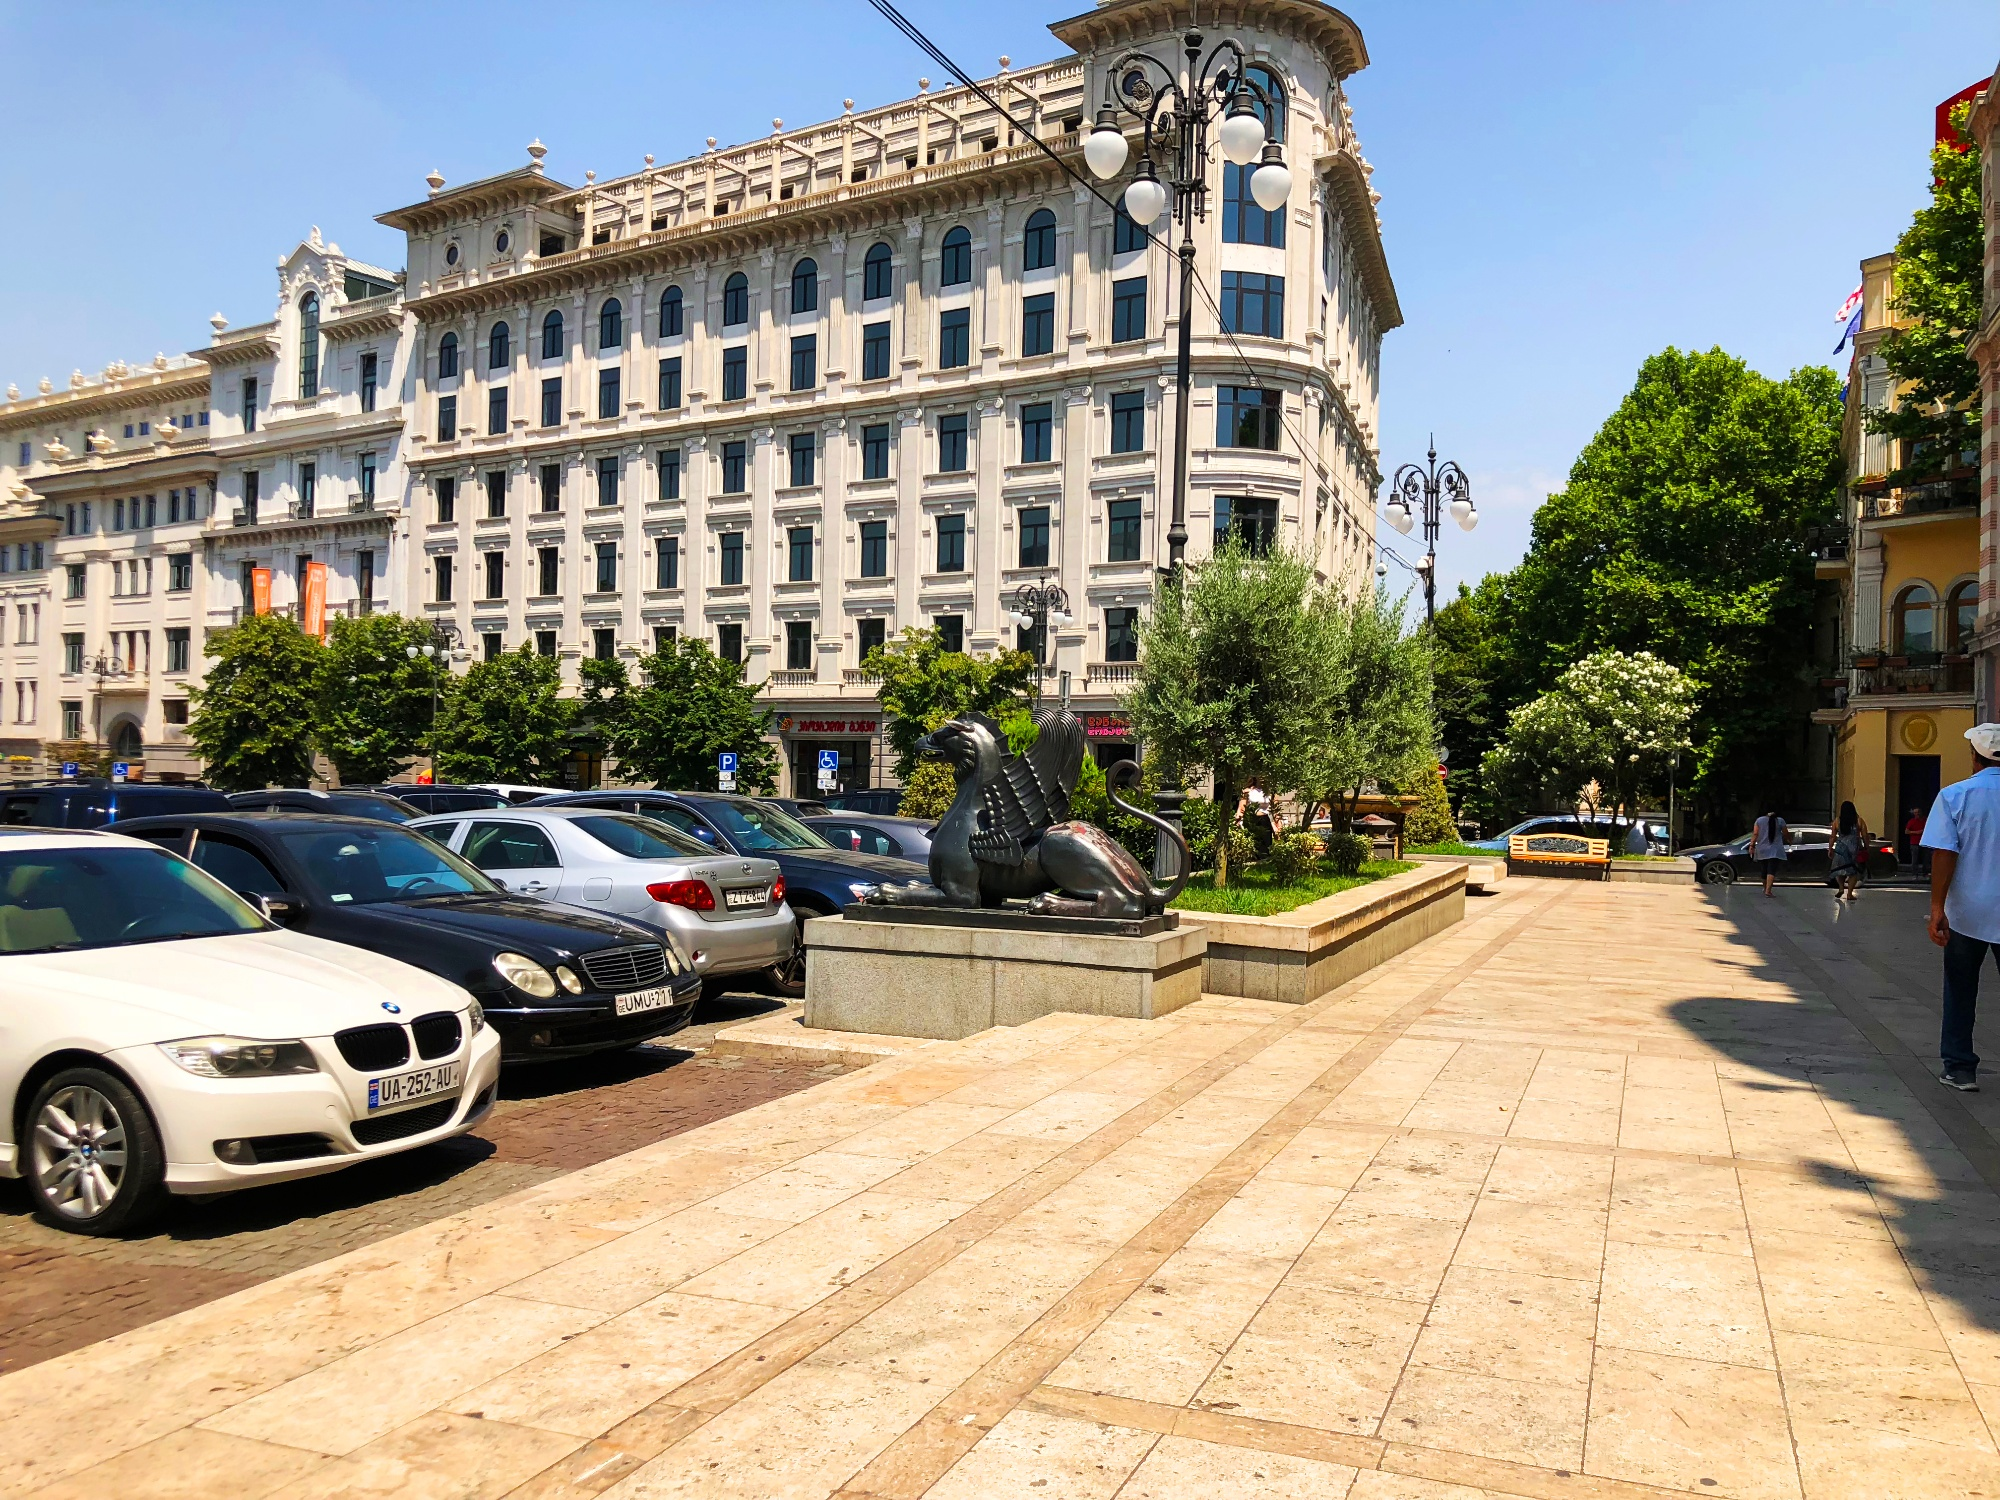Imagine a story behind the person walking past the lion statue. The man walking past the lion statue could be a local historian. Enthralled by the stories etched into the fabric of his city, he takes these strolls to immerse himself in its history. Perhaps he's on his way to meet with a group of eager tourists, to whom he'll reveal the lesser-known tales behind the city's landmarks, including the very statue he's passing by—a silent guardian of countless stories. 